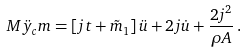<formula> <loc_0><loc_0><loc_500><loc_500>M \ddot { y } _ { c } m = \left [ j t + \tilde { m } _ { 1 } \right ] \ddot { u } + 2 j \dot { u } + \frac { 2 j ^ { 2 } } { \rho A } \, .</formula> 